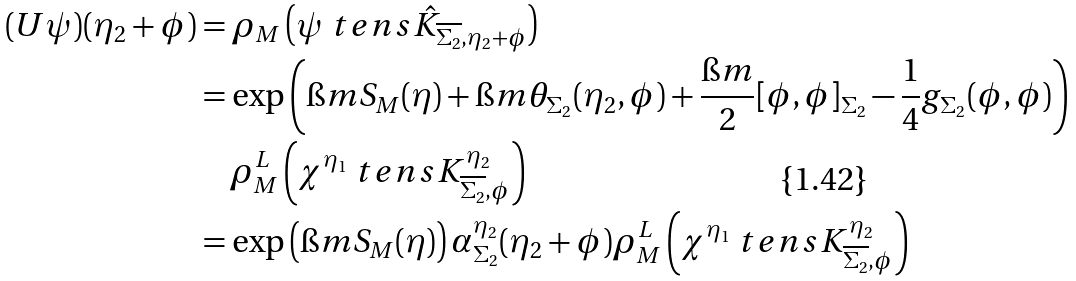<formula> <loc_0><loc_0><loc_500><loc_500>( U \psi ) ( \eta _ { 2 } + \phi ) & = \rho _ { M } \left ( \psi \ t e n s \hat { K } _ { \overline { \Sigma _ { 2 } } , \eta _ { 2 } + \phi } \right ) \\ & = \exp \left ( \i m S _ { M } ( \eta ) + \i m \theta _ { \Sigma _ { 2 } } ( \eta _ { 2 } , \phi ) + \frac { \i m } { 2 } [ \phi , \phi ] _ { \Sigma _ { 2 } } - \frac { 1 } { 4 } g _ { \Sigma _ { 2 } } ( \phi , \phi ) \right ) \\ & \quad \rho _ { M } ^ { L } \left ( \chi ^ { \eta _ { 1 } } \ t e n s K ^ { \eta _ { 2 } } _ { \overline { \Sigma _ { 2 } } , \phi } \right ) \\ & = \exp \left ( \i m S _ { M } ( \eta ) \right ) \alpha _ { \Sigma _ { 2 } } ^ { \eta _ { 2 } } ( \eta _ { 2 } + \phi ) \rho _ { M } ^ { L } \left ( \chi ^ { \eta _ { 1 } } \ t e n s K ^ { \eta _ { 2 } } _ { \overline { \Sigma _ { 2 } } , \phi } \right )</formula> 